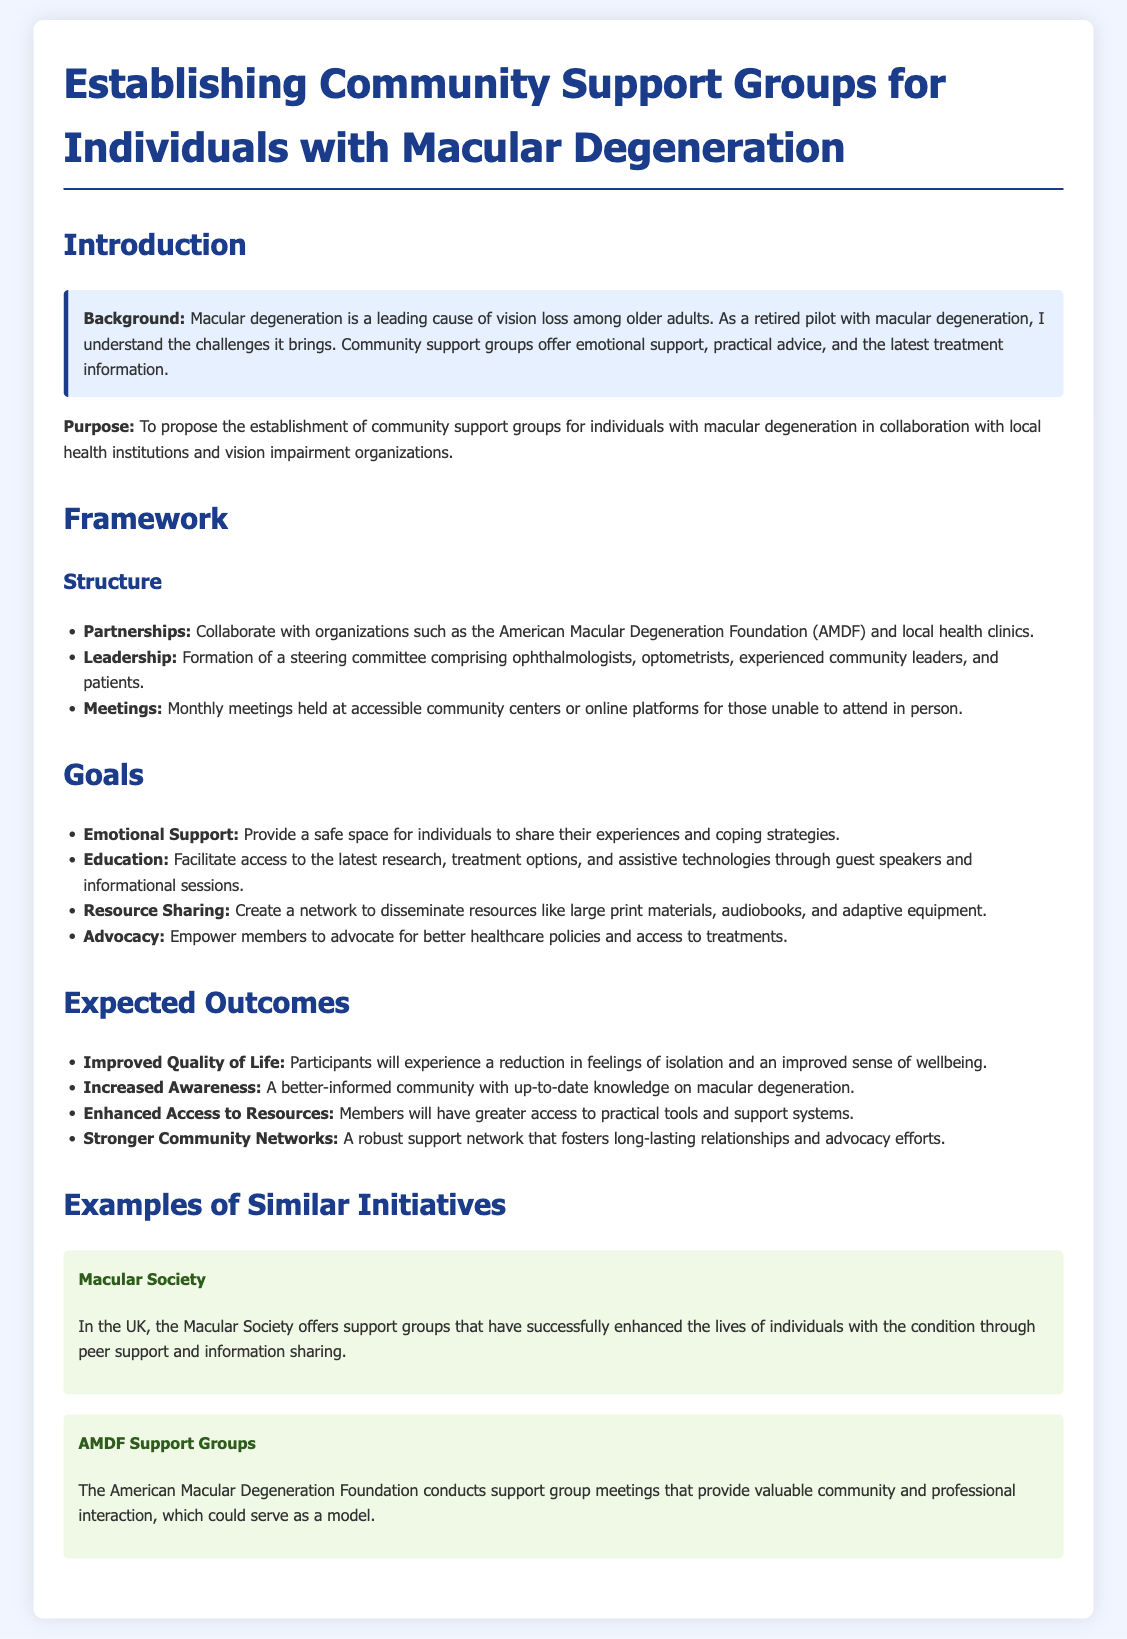what is the primary purpose of the proposal? The purpose is to propose the establishment of community support groups for individuals with macular degeneration.
Answer: establishment of community support groups who are the proposed partners for this initiative? Collaborations will be made with organizations such as the American Macular Degeneration Foundation and local health clinics.
Answer: American Macular Degeneration Foundation, local health clinics how often will meetings be held? The document states that meetings will be held monthly.
Answer: monthly what is one goal of the community support groups? One goal is to provide emotional support for individuals sharing their experiences.
Answer: emotional support which initiative is mentioned as an example from the UK? The Macular Society is highlighted as a successful initiative in the UK.
Answer: Macular Society what is an expected outcome for participants? Participants will experience improved quality of life.
Answer: improved quality of life who will form the leadership for the support groups? A steering committee comprising ophthalmologists, optometrists, experienced community leaders, and patients will lead.
Answer: ophthalmologists, optometrists, community leaders, patients what does the document emphasize about resource sharing? The initiative aims to create a network to disseminate resources like large print materials and audiobooks.
Answer: large print materials, audiobooks 